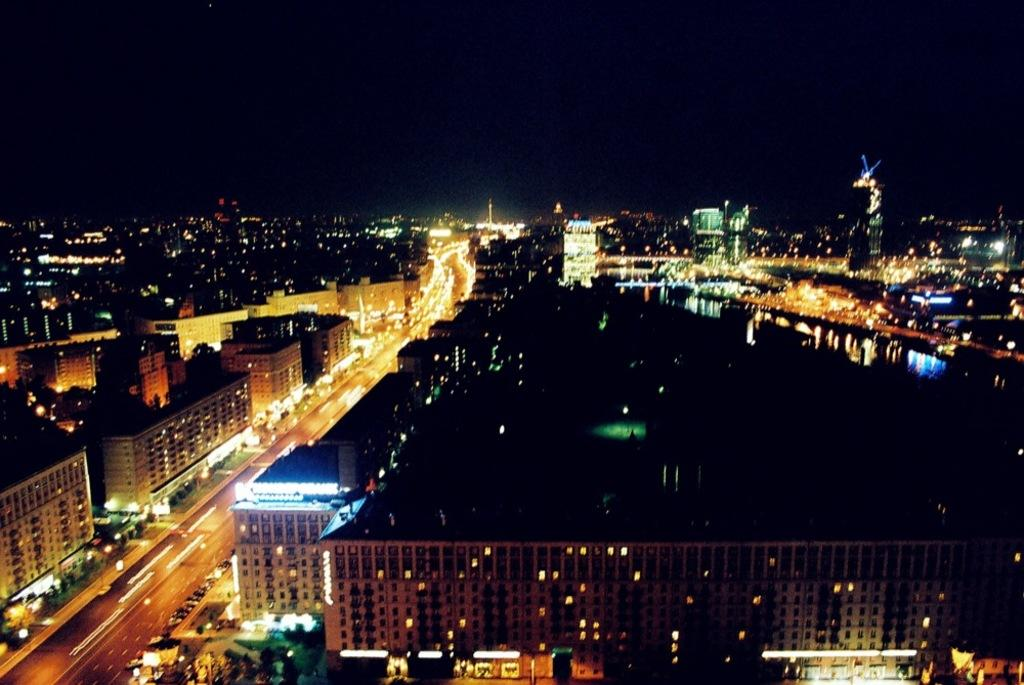What can be seen on the buildings in the image? There are lights on the buildings in the image. What can be seen on the road in the image? White lines are visible on the road in the image. How would you describe the top part of the image? The top part of the image has a dark view. Can you tell me where the mom is taking the child for treatment in the image? There is no mom, child, or treatment present in the image. What type of animals can be seen at the zoo in the image? There is no zoo or animals present in the image. 